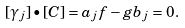Convert formula to latex. <formula><loc_0><loc_0><loc_500><loc_500>[ \gamma _ { j } ] \bullet [ C ] = a _ { j } f - g b _ { j } = 0 .</formula> 